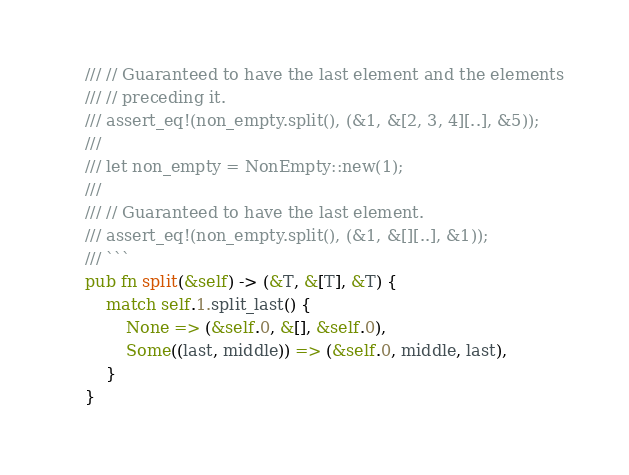<code> <loc_0><loc_0><loc_500><loc_500><_Rust_>    /// // Guaranteed to have the last element and the elements
    /// // preceding it.
    /// assert_eq!(non_empty.split(), (&1, &[2, 3, 4][..], &5));
    ///
    /// let non_empty = NonEmpty::new(1);
    ///
    /// // Guaranteed to have the last element.
    /// assert_eq!(non_empty.split(), (&1, &[][..], &1));
    /// ```
    pub fn split(&self) -> (&T, &[T], &T) {
        match self.1.split_last() {
            None => (&self.0, &[], &self.0),
            Some((last, middle)) => (&self.0, middle, last),
        }
    }
</code> 